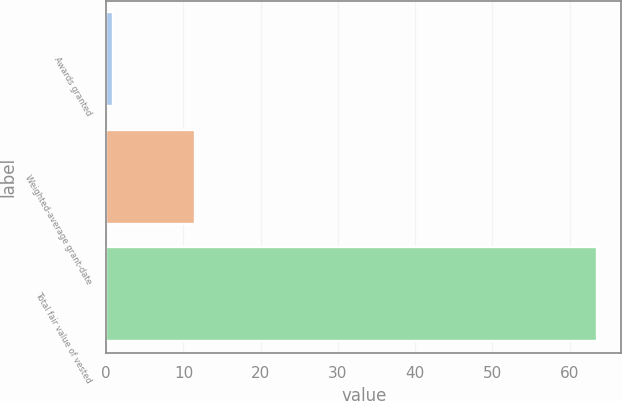<chart> <loc_0><loc_0><loc_500><loc_500><bar_chart><fcel>Awards granted<fcel>Weighted-average grant-date<fcel>Total fair value of vested<nl><fcel>0.9<fcel>11.43<fcel>63.5<nl></chart> 